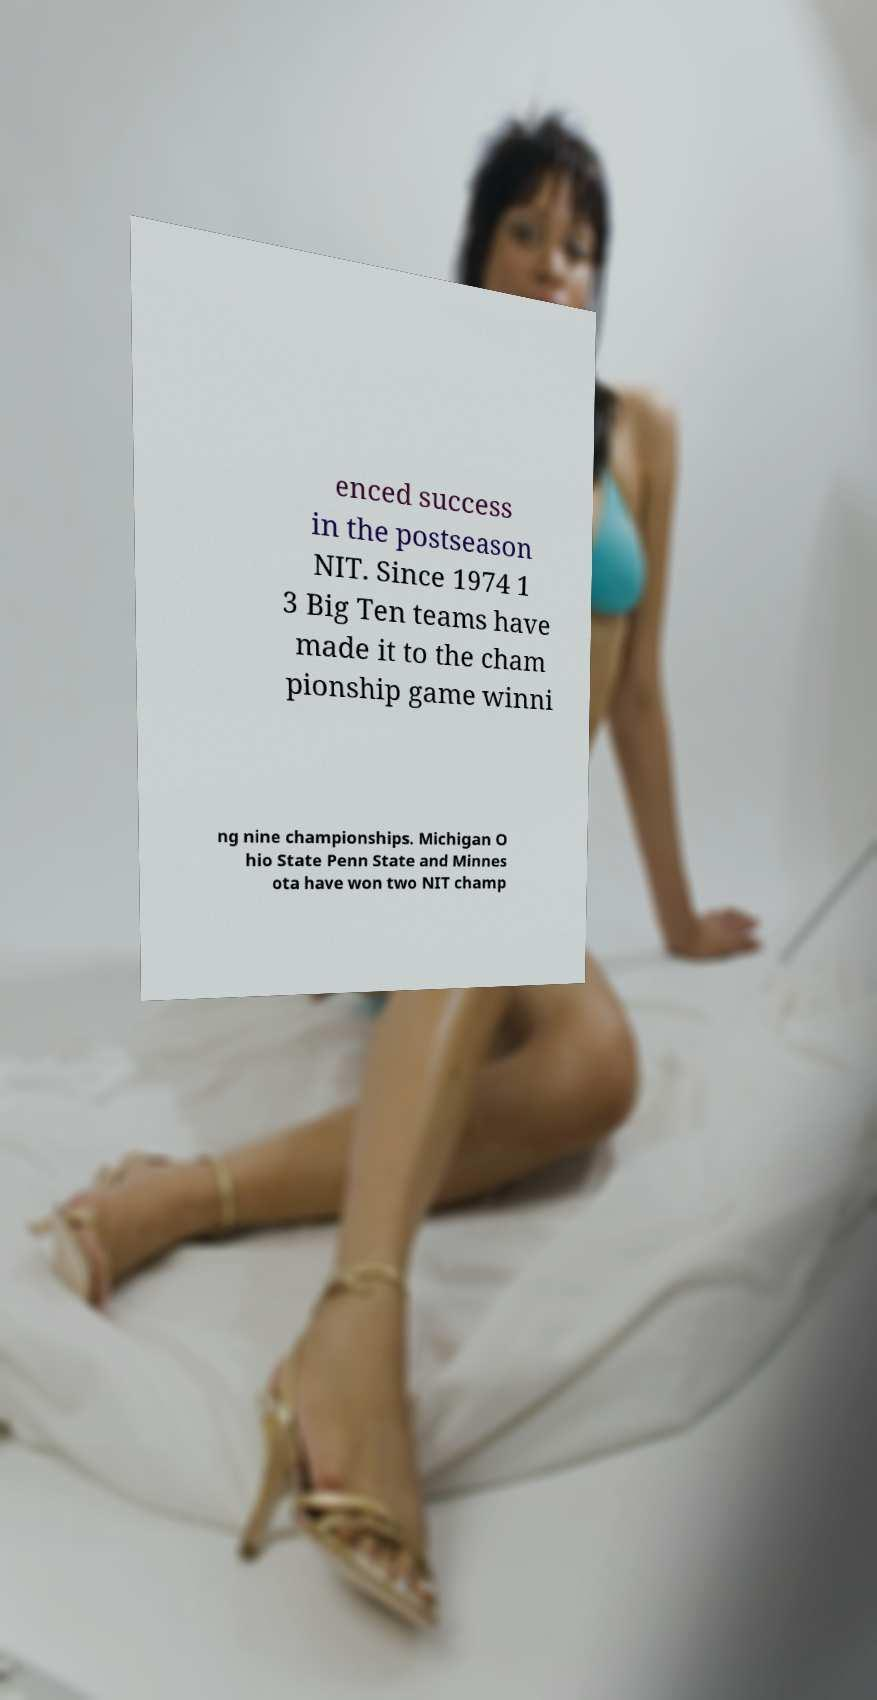There's text embedded in this image that I need extracted. Can you transcribe it verbatim? enced success in the postseason NIT. Since 1974 1 3 Big Ten teams have made it to the cham pionship game winni ng nine championships. Michigan O hio State Penn State and Minnes ota have won two NIT champ 